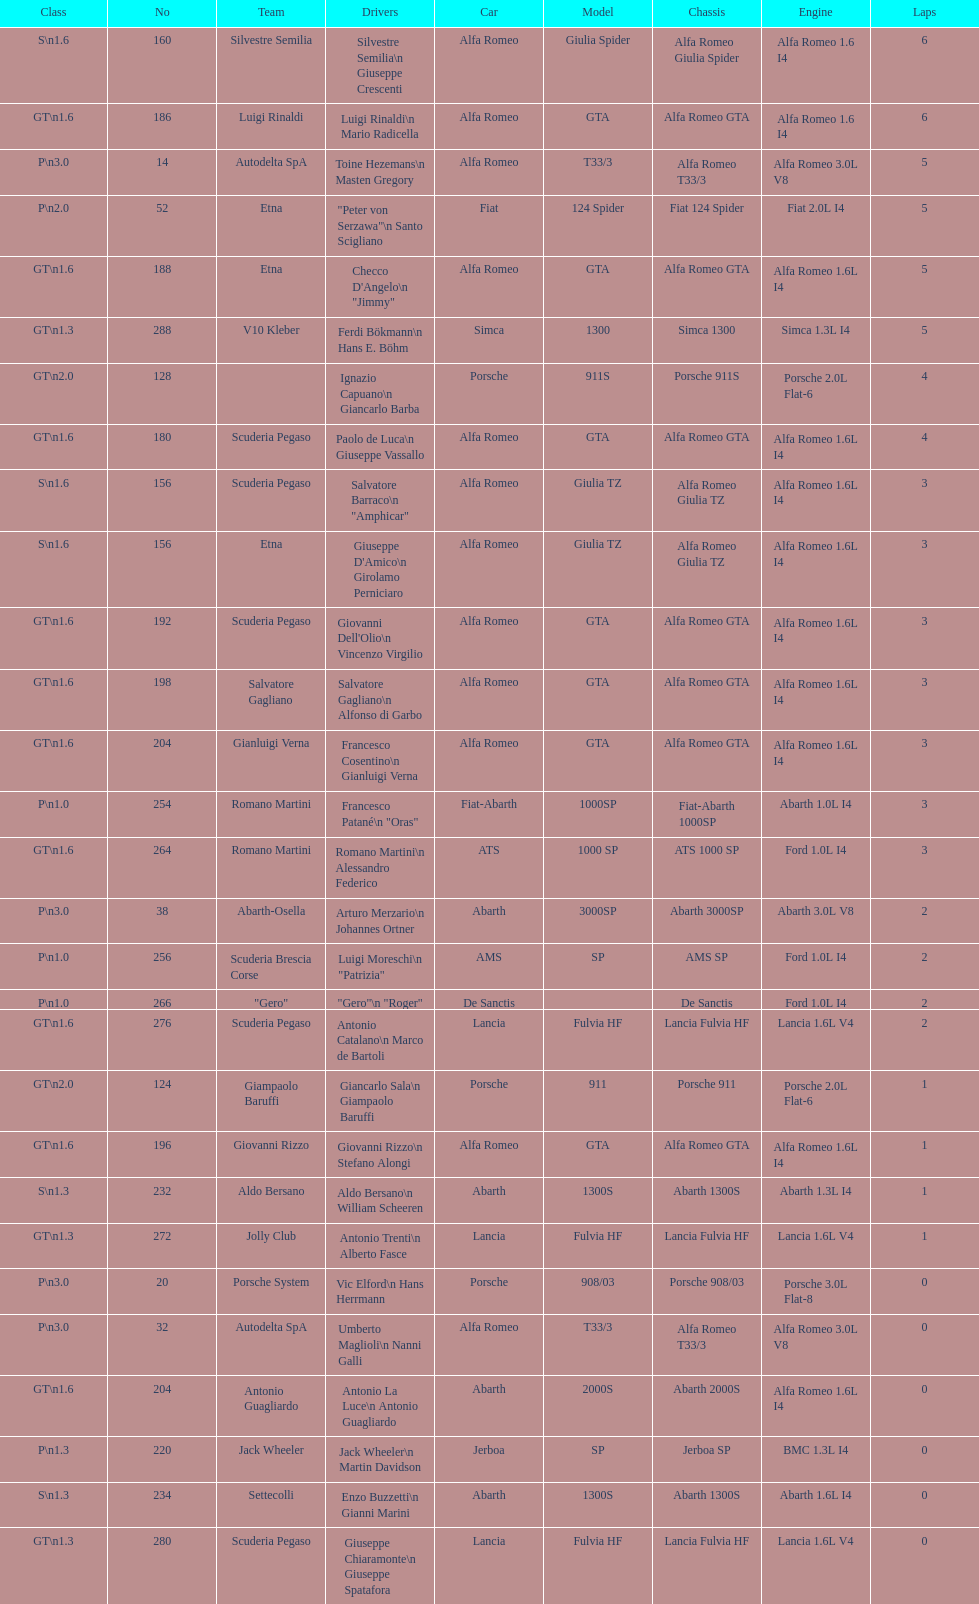How many laps does v10 kleber have? 5. 